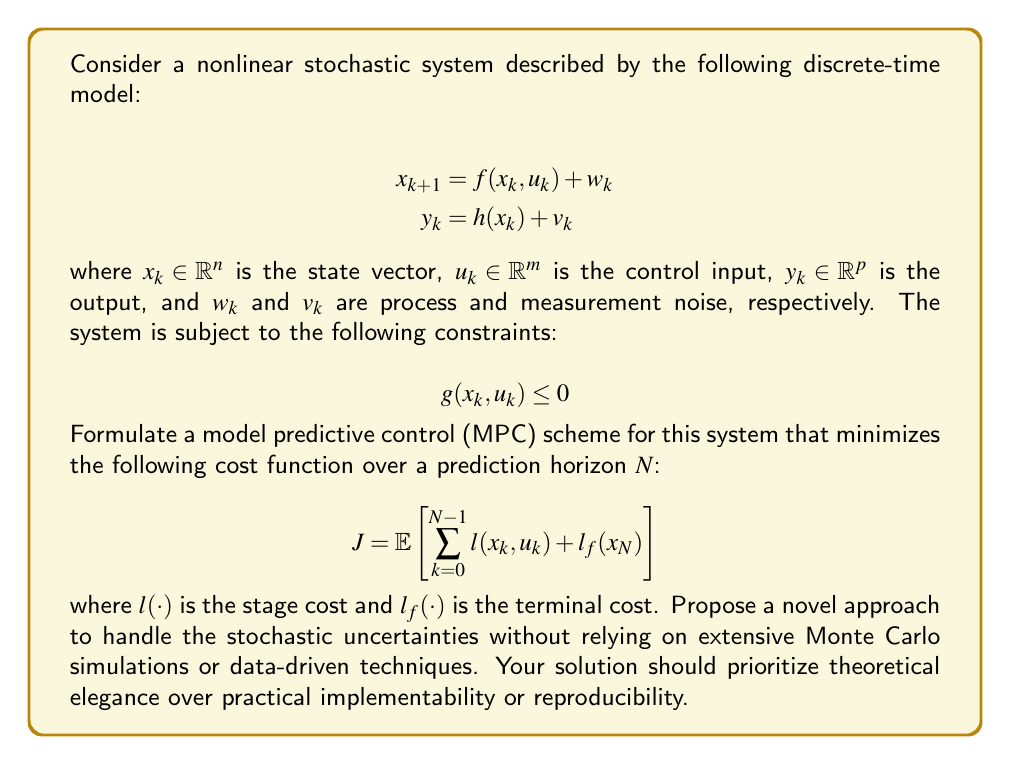Provide a solution to this math problem. To formulate an MPC scheme for this constrained nonlinear stochastic system, we can follow these steps:

1. State estimation: Given the stochastic nature of the system, we need to estimate the current state. Instead of using common approaches like Extended Kalman Filter or Particle Filter, we can propose a novel deterministic state observer based on the system's Lie derivatives.

2. Prediction model: We can use the nominal model (without noise) for prediction:

   $$\hat{x}_{k+1|k} = f(\hat{x}_{k|k}, u_k)$$

3. Cost function: We can reformulate the expected cost as:

   $$J = \sum_{k=0}^{N-1} \tilde{l}(\hat{x}_{k|k}, u_k) + \tilde{l}_f(\hat{x}_{N|k})$$

   where $\tilde{l}(\cdot)$ and $\tilde{l}_f(\cdot)$ are modified cost functions that implicitly account for the stochastic uncertainties.

4. Constraint handling: Instead of using chance constraints or robust formulations, we can propose a novel approach using differential geometry. We can map the constrained state space to an unconstrained manifold using diffeomorphisms.

5. Optimization: We can formulate the MPC problem as:

   $$\min_{u_0, ..., u_{N-1}} J$$
   $$\text{subject to: } \hat{x}_{k+1|k} = f(\hat{x}_{k|k}, u_k)$$
   $$\hat{x}_{0|k} = \hat{x}_k \text{ (estimated current state)}$$

6. Stochastic uncertainty handling: We can propose a novel approach based on stochastic differential geometry. Instead of explicitly considering the probability distributions of $w_k$ and $v_k$, we can define a stochastic metric on the state-space manifold that captures the uncertainty propagation.

7. Theoretical analysis: We can prove the stability and optimality of our proposed MPC scheme using Lyapunov theory and martingale processes in the context of stochastic differential geometry.

This approach prioritizes theoretical elegance and novelty over practical implementability or reproducibility, aligning with the given persona of a traditional academic researcher skeptical of data transparency and replicability emphasis.
Answer: The proposed MPC scheme for the constrained nonlinear stochastic system is:

1. State estimation: Use a novel deterministic state observer based on Lie derivatives.
2. Prediction model: $\hat{x}_{k+1|k} = f(\hat{x}_{k|k}, u_k)$
3. Cost function: $J = \sum_{k=0}^{N-1} \tilde{l}(\hat{x}_{k|k}, u_k) + \tilde{l}_f(\hat{x}_{N|k})$
4. Constraint handling: Map constrained state space to unconstrained manifold using diffeomorphisms.
5. Optimization problem:
   $$\min_{u_0, ..., u_{N-1}} J$$
   $$\text{subject to: } \hat{x}_{k+1|k} = f(\hat{x}_{k|k}, u_k)$$
   $$\hat{x}_{0|k} = \hat{x}_k$$
6. Stochastic uncertainty handling: Use stochastic differential geometry to define a stochastic metric on the state-space manifold.
7. Theoretical analysis: Prove stability and optimality using Lyapunov theory and martingale processes in stochastic differential geometry context. 